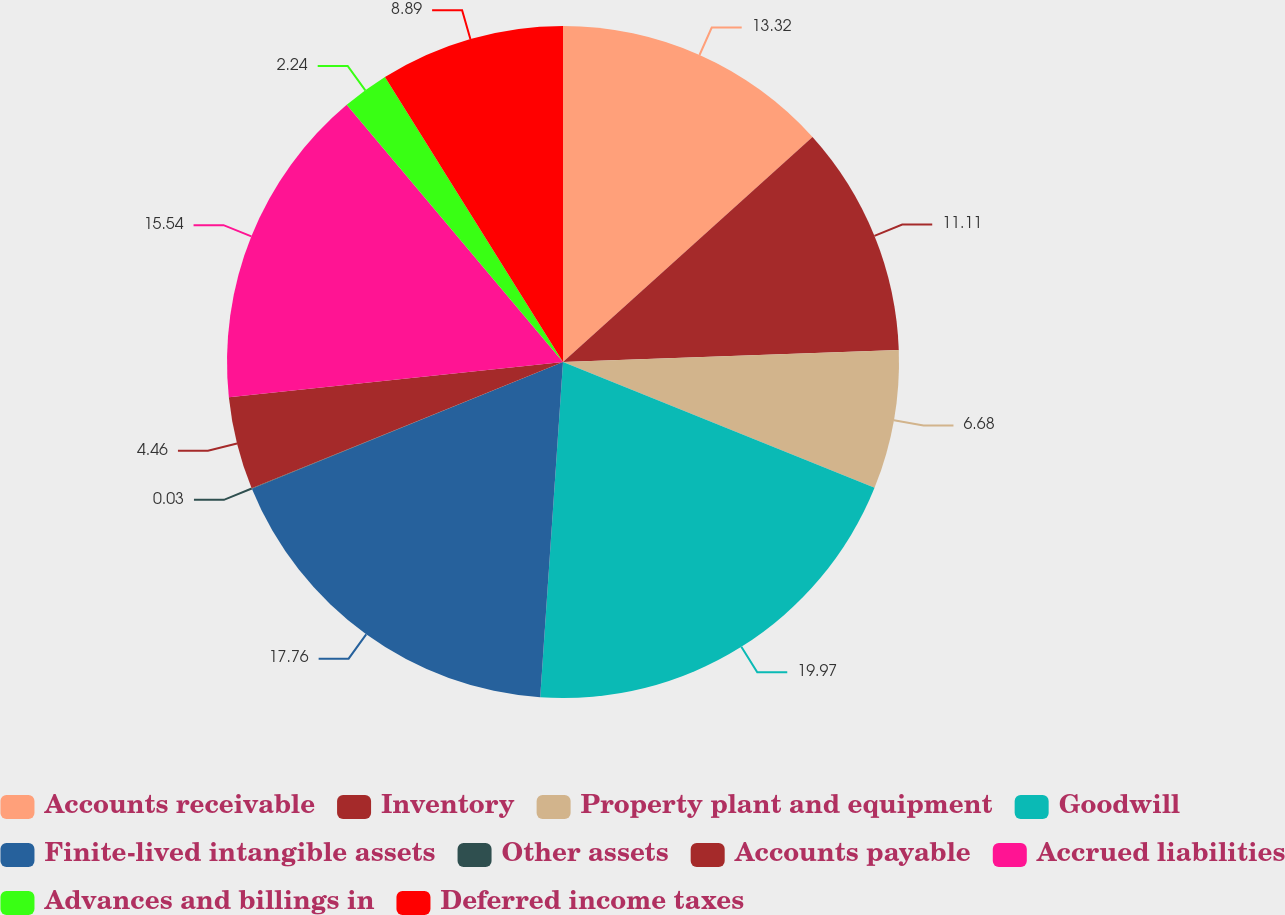<chart> <loc_0><loc_0><loc_500><loc_500><pie_chart><fcel>Accounts receivable<fcel>Inventory<fcel>Property plant and equipment<fcel>Goodwill<fcel>Finite-lived intangible assets<fcel>Other assets<fcel>Accounts payable<fcel>Accrued liabilities<fcel>Advances and billings in<fcel>Deferred income taxes<nl><fcel>13.32%<fcel>11.11%<fcel>6.68%<fcel>19.97%<fcel>17.76%<fcel>0.03%<fcel>4.46%<fcel>15.54%<fcel>2.24%<fcel>8.89%<nl></chart> 